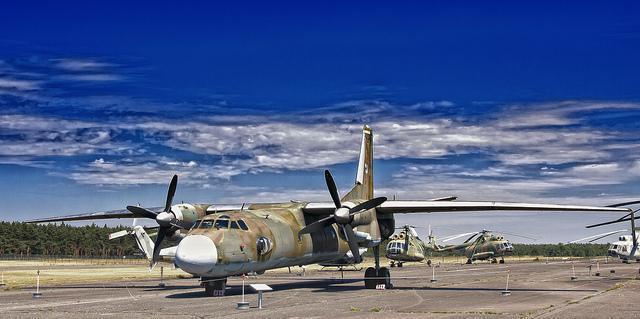What are the four things on each side of the vehicle called?
Select the accurate response from the four choices given to answer the question.
Options: Missiles, propellers, windows, tires. Propellers. 